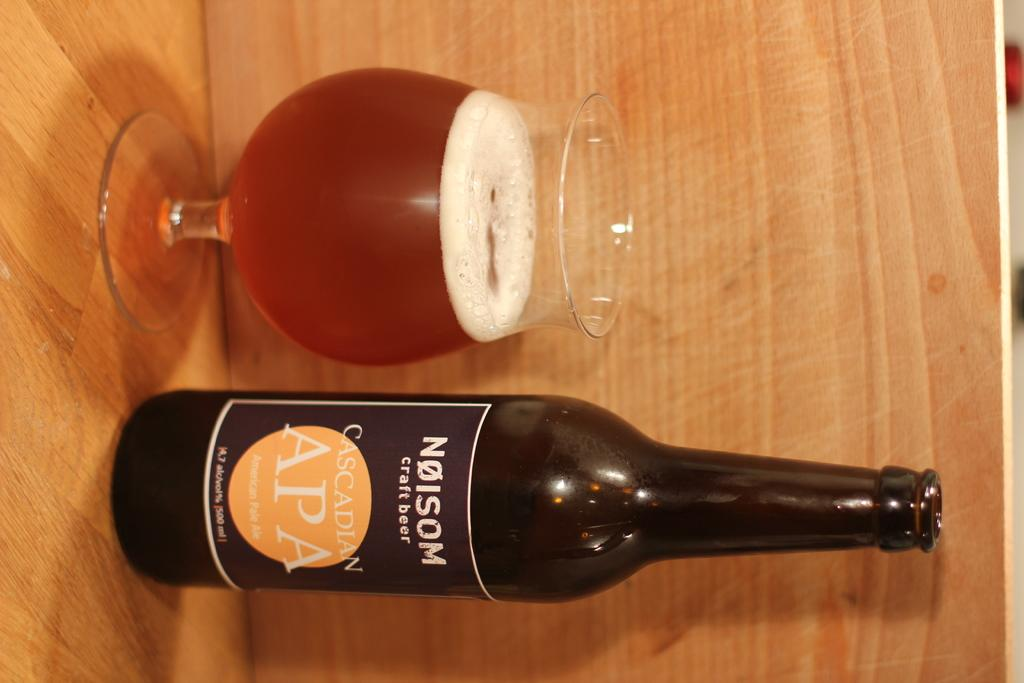<image>
Summarize the visual content of the image. A glass of beer placed next to a bottle of craft beer with a label that says Cascadian APA. 